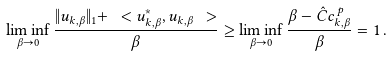Convert formula to latex. <formula><loc_0><loc_0><loc_500><loc_500>\liminf _ { \beta \to 0 } \frac { \| u _ { k , \beta } \| _ { 1 } + \ < u ^ { * } _ { k , \beta } , u _ { k , \beta } \ > } { \beta } & \geq \liminf _ { \beta \to 0 } \frac { \beta - \hat { C } c _ { k , \beta } ^ { \, p } } { \beta } = 1 \, .</formula> 